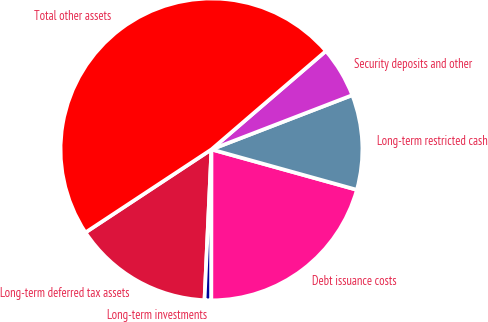Convert chart to OTSL. <chart><loc_0><loc_0><loc_500><loc_500><pie_chart><fcel>Long-term deferred tax assets<fcel>Long-term investments<fcel>Debt issuance costs<fcel>Long-term restricted cash<fcel>Security deposits and other<fcel>Total other assets<nl><fcel>14.99%<fcel>0.72%<fcel>20.7%<fcel>10.17%<fcel>5.45%<fcel>47.97%<nl></chart> 